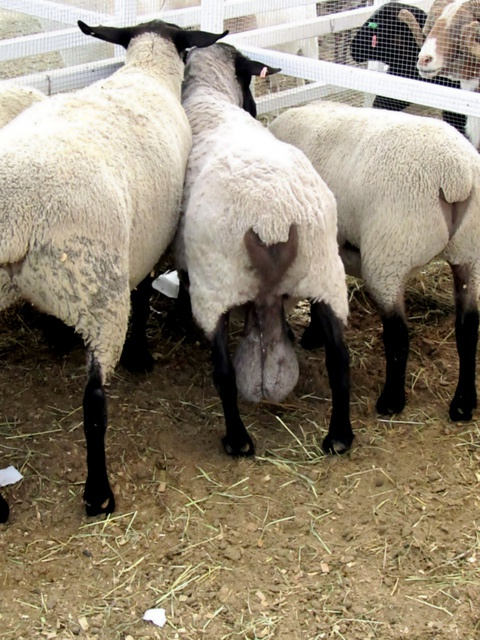Describe the objects in this image and their specific colors. I can see sheep in white, ivory, tan, and black tones, sheep in white, black, lightgray, darkgray, and gray tones, sheep in white, darkgray, ivory, black, and lightgray tones, sheep in white, black, gray, lightgray, and darkgray tones, and sheep in white, darkgray, gray, and lightgray tones in this image. 